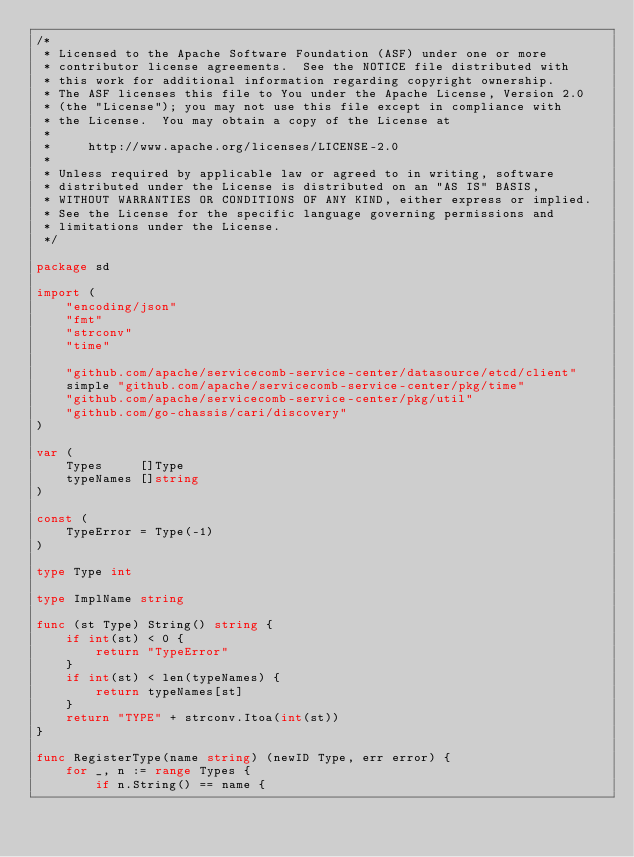<code> <loc_0><loc_0><loc_500><loc_500><_Go_>/*
 * Licensed to the Apache Software Foundation (ASF) under one or more
 * contributor license agreements.  See the NOTICE file distributed with
 * this work for additional information regarding copyright ownership.
 * The ASF licenses this file to You under the Apache License, Version 2.0
 * (the "License"); you may not use this file except in compliance with
 * the License.  You may obtain a copy of the License at
 *
 *     http://www.apache.org/licenses/LICENSE-2.0
 *
 * Unless required by applicable law or agreed to in writing, software
 * distributed under the License is distributed on an "AS IS" BASIS,
 * WITHOUT WARRANTIES OR CONDITIONS OF ANY KIND, either express or implied.
 * See the License for the specific language governing permissions and
 * limitations under the License.
 */

package sd

import (
	"encoding/json"
	"fmt"
	"strconv"
	"time"

	"github.com/apache/servicecomb-service-center/datasource/etcd/client"
	simple "github.com/apache/servicecomb-service-center/pkg/time"
	"github.com/apache/servicecomb-service-center/pkg/util"
	"github.com/go-chassis/cari/discovery"
)

var (
	Types     []Type
	typeNames []string
)

const (
	TypeError = Type(-1)
)

type Type int

type ImplName string

func (st Type) String() string {
	if int(st) < 0 {
		return "TypeError"
	}
	if int(st) < len(typeNames) {
		return typeNames[st]
	}
	return "TYPE" + strconv.Itoa(int(st))
}

func RegisterType(name string) (newID Type, err error) {
	for _, n := range Types {
		if n.String() == name {</code> 